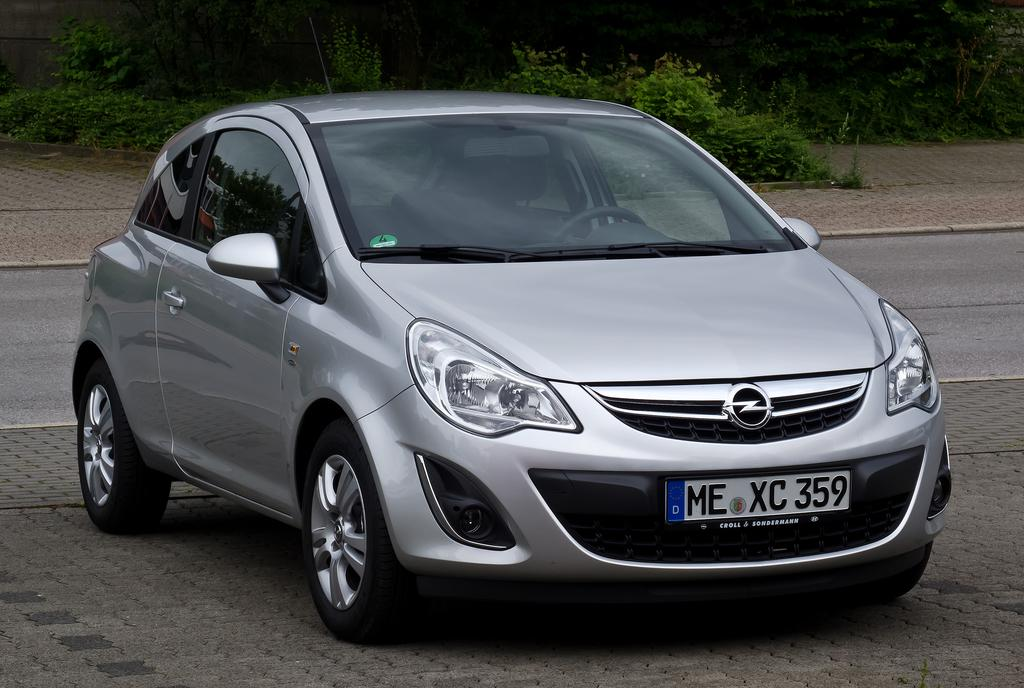What type of vehicle is in the image? There is a silver-colored car in the image. What is behind the car in the image? There is a road behind the car. What can be seen in the distance in the image? In the distance, there are green trees. What type of comb is being used to groom the bee in the image? There is no comb or bee present in the image; it features a silver-colored car, a road, and green trees in the distance. 